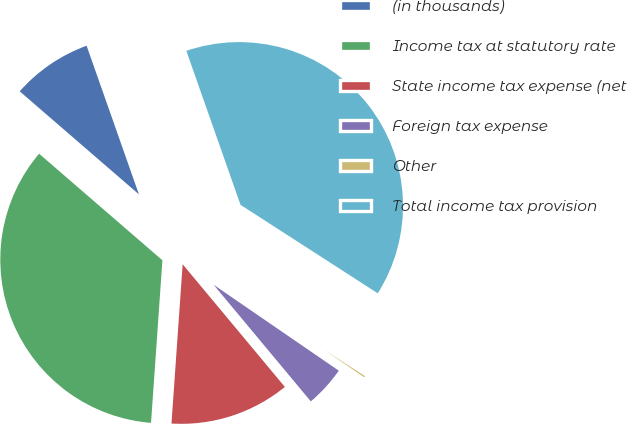Convert chart. <chart><loc_0><loc_0><loc_500><loc_500><pie_chart><fcel>(in thousands)<fcel>Income tax at statutory rate<fcel>State income tax expense (net<fcel>Foreign tax expense<fcel>Other<fcel>Total income tax provision<nl><fcel>8.27%<fcel>35.23%<fcel>12.17%<fcel>4.37%<fcel>0.46%<fcel>39.5%<nl></chart> 